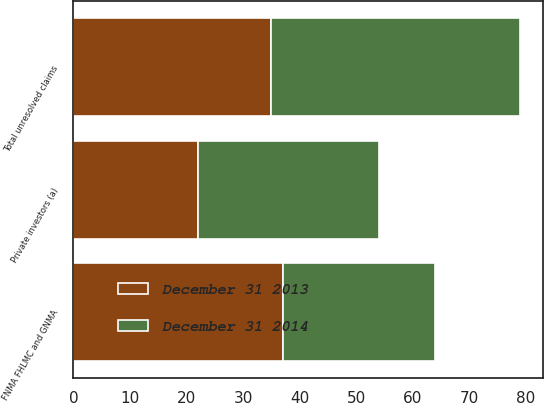<chart> <loc_0><loc_0><loc_500><loc_500><stacked_bar_chart><ecel><fcel>FNMA FHLMC and GNMA<fcel>Private investors (a)<fcel>Total unresolved claims<nl><fcel>December 31 2014<fcel>27<fcel>32<fcel>44<nl><fcel>December 31 2013<fcel>37<fcel>22<fcel>35<nl></chart> 